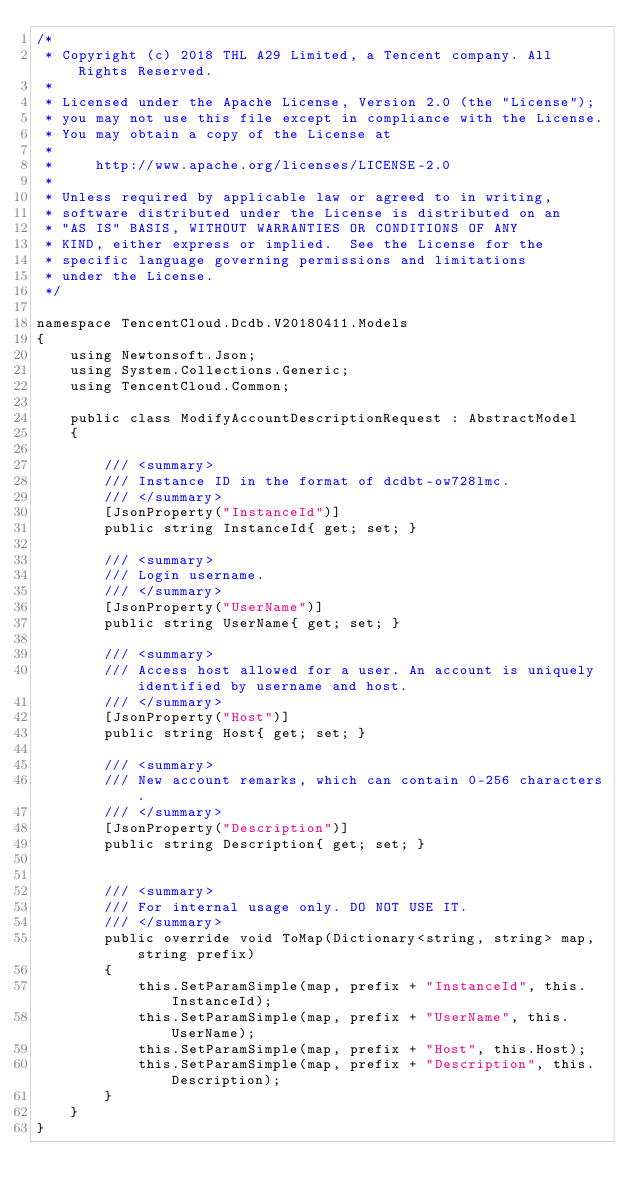<code> <loc_0><loc_0><loc_500><loc_500><_C#_>/*
 * Copyright (c) 2018 THL A29 Limited, a Tencent company. All Rights Reserved.
 *
 * Licensed under the Apache License, Version 2.0 (the "License");
 * you may not use this file except in compliance with the License.
 * You may obtain a copy of the License at
 *
 *     http://www.apache.org/licenses/LICENSE-2.0
 *
 * Unless required by applicable law or agreed to in writing,
 * software distributed under the License is distributed on an
 * "AS IS" BASIS, WITHOUT WARRANTIES OR CONDITIONS OF ANY
 * KIND, either express or implied.  See the License for the
 * specific language governing permissions and limitations
 * under the License.
 */

namespace TencentCloud.Dcdb.V20180411.Models
{
    using Newtonsoft.Json;
    using System.Collections.Generic;
    using TencentCloud.Common;

    public class ModifyAccountDescriptionRequest : AbstractModel
    {
        
        /// <summary>
        /// Instance ID in the format of dcdbt-ow728lmc.
        /// </summary>
        [JsonProperty("InstanceId")]
        public string InstanceId{ get; set; }

        /// <summary>
        /// Login username.
        /// </summary>
        [JsonProperty("UserName")]
        public string UserName{ get; set; }

        /// <summary>
        /// Access host allowed for a user. An account is uniquely identified by username and host.
        /// </summary>
        [JsonProperty("Host")]
        public string Host{ get; set; }

        /// <summary>
        /// New account remarks, which can contain 0-256 characters.
        /// </summary>
        [JsonProperty("Description")]
        public string Description{ get; set; }


        /// <summary>
        /// For internal usage only. DO NOT USE IT.
        /// </summary>
        public override void ToMap(Dictionary<string, string> map, string prefix)
        {
            this.SetParamSimple(map, prefix + "InstanceId", this.InstanceId);
            this.SetParamSimple(map, prefix + "UserName", this.UserName);
            this.SetParamSimple(map, prefix + "Host", this.Host);
            this.SetParamSimple(map, prefix + "Description", this.Description);
        }
    }
}

</code> 